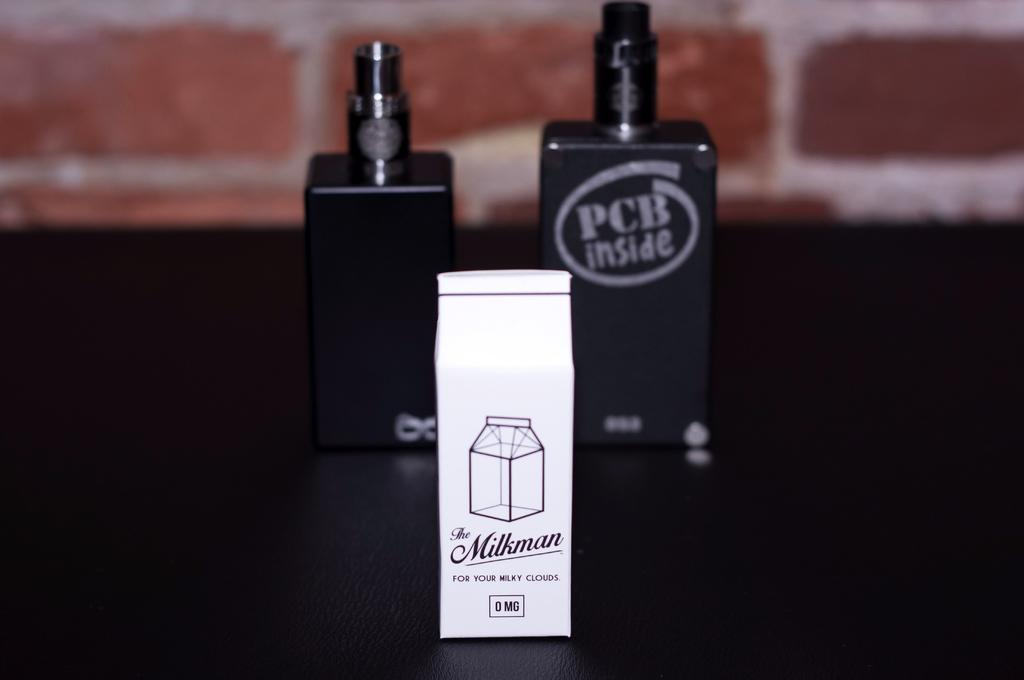<image>
Write a terse but informative summary of the picture. A small white carton named "The Milkman" in front of a vape. 